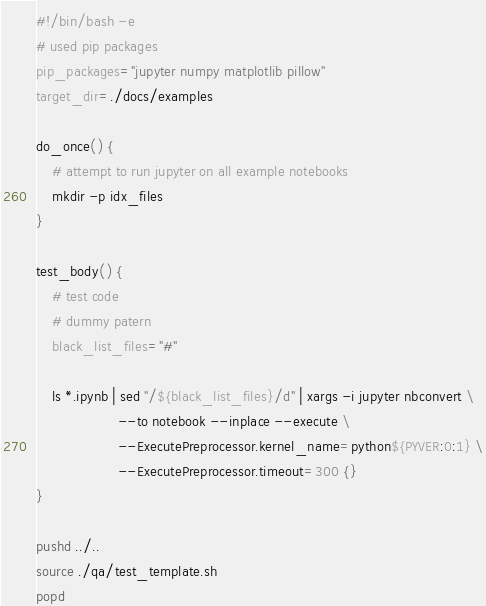Convert code to text. <code><loc_0><loc_0><loc_500><loc_500><_Bash_>#!/bin/bash -e
# used pip packages
pip_packages="jupyter numpy matplotlib pillow"
target_dir=./docs/examples

do_once() {
    # attempt to run jupyter on all example notebooks
    mkdir -p idx_files
}

test_body() {
    # test code
    # dummy patern
    black_list_files="#"

    ls *.ipynb | sed "/${black_list_files}/d" | xargs -i jupyter nbconvert \
                    --to notebook --inplace --execute \
                    --ExecutePreprocessor.kernel_name=python${PYVER:0:1} \
                    --ExecutePreprocessor.timeout=300 {}
}

pushd ../..
source ./qa/test_template.sh
popd
</code> 